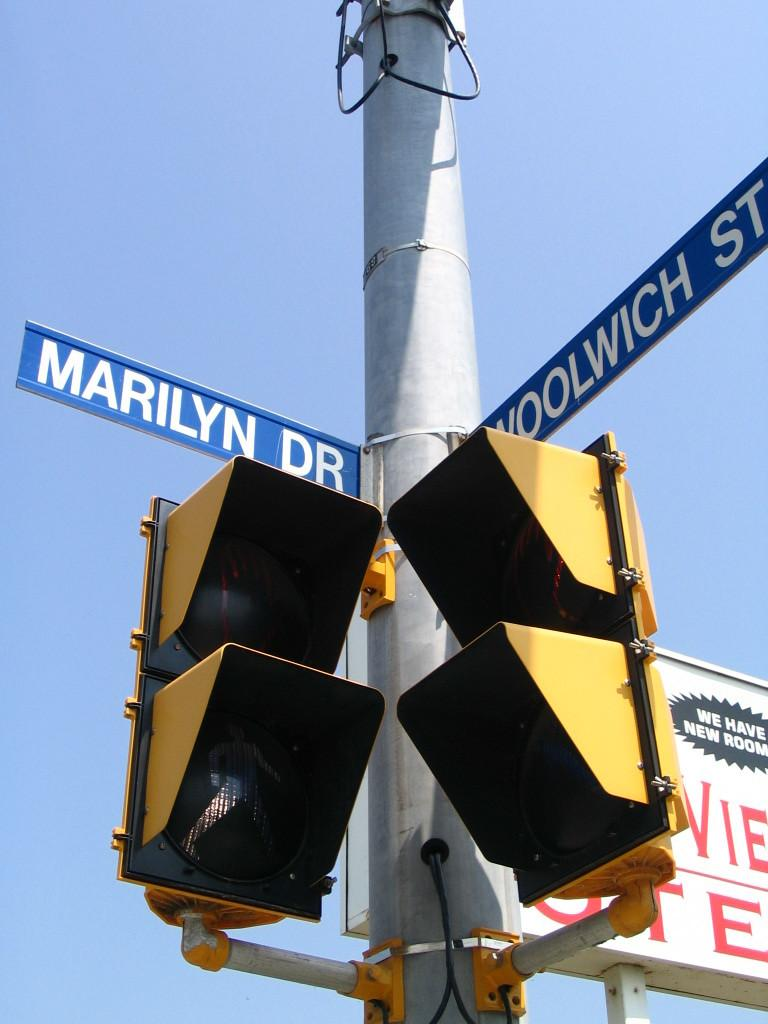<image>
Render a clear and concise summary of the photo. A picture of two street signs, Marilyn Dr and Woolwich st. 